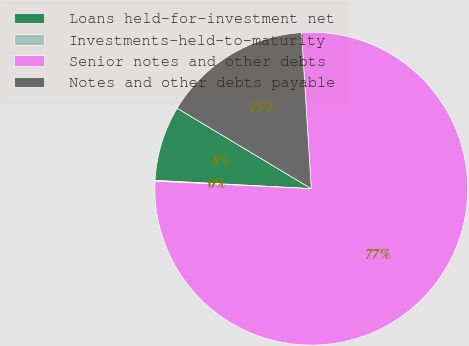Convert chart to OTSL. <chart><loc_0><loc_0><loc_500><loc_500><pie_chart><fcel>Loans held-for-investment net<fcel>Investments-held-to-maturity<fcel>Senior notes and other debts<fcel>Notes and other debts payable<nl><fcel>7.75%<fcel>0.08%<fcel>76.76%<fcel>15.41%<nl></chart> 